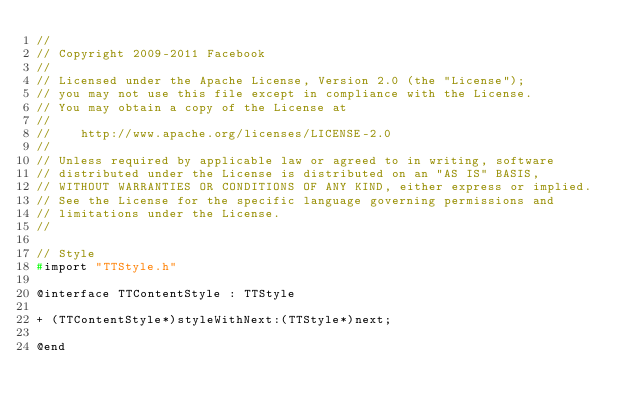<code> <loc_0><loc_0><loc_500><loc_500><_C_>//
// Copyright 2009-2011 Facebook
//
// Licensed under the Apache License, Version 2.0 (the "License");
// you may not use this file except in compliance with the License.
// You may obtain a copy of the License at
//
//    http://www.apache.org/licenses/LICENSE-2.0
//
// Unless required by applicable law or agreed to in writing, software
// distributed under the License is distributed on an "AS IS" BASIS,
// WITHOUT WARRANTIES OR CONDITIONS OF ANY KIND, either express or implied.
// See the License for the specific language governing permissions and
// limitations under the License.
//

// Style
#import "TTStyle.h"

@interface TTContentStyle : TTStyle

+ (TTContentStyle*)styleWithNext:(TTStyle*)next;

@end
</code> 